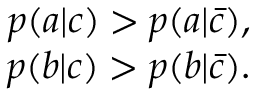Convert formula to latex. <formula><loc_0><loc_0><loc_500><loc_500>\begin{array} { r } { p ( a | c ) > p ( a | \bar { c } ) , } \\ { p ( b | c ) > p ( b | \bar { c } ) . } \end{array}</formula> 